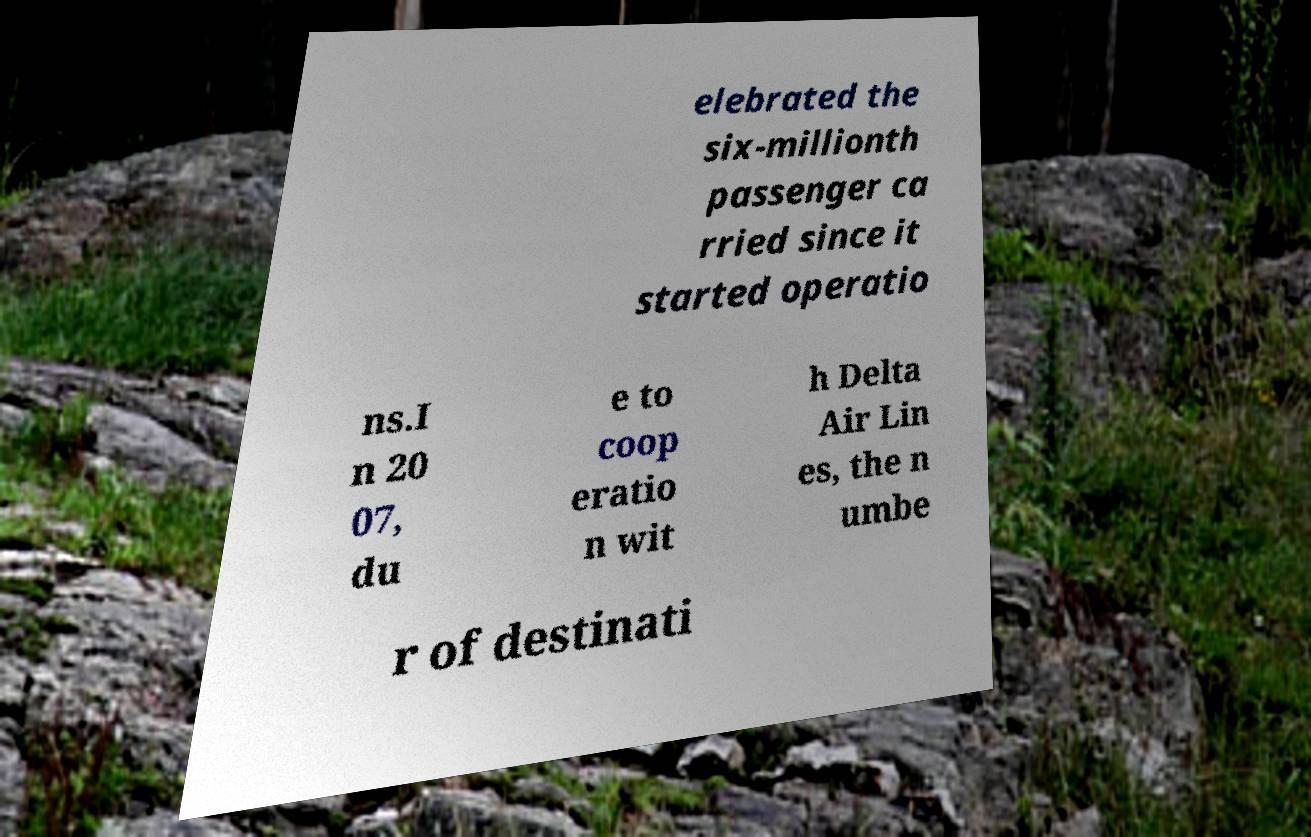What messages or text are displayed in this image? I need them in a readable, typed format. elebrated the six-millionth passenger ca rried since it started operatio ns.I n 20 07, du e to coop eratio n wit h Delta Air Lin es, the n umbe r of destinati 